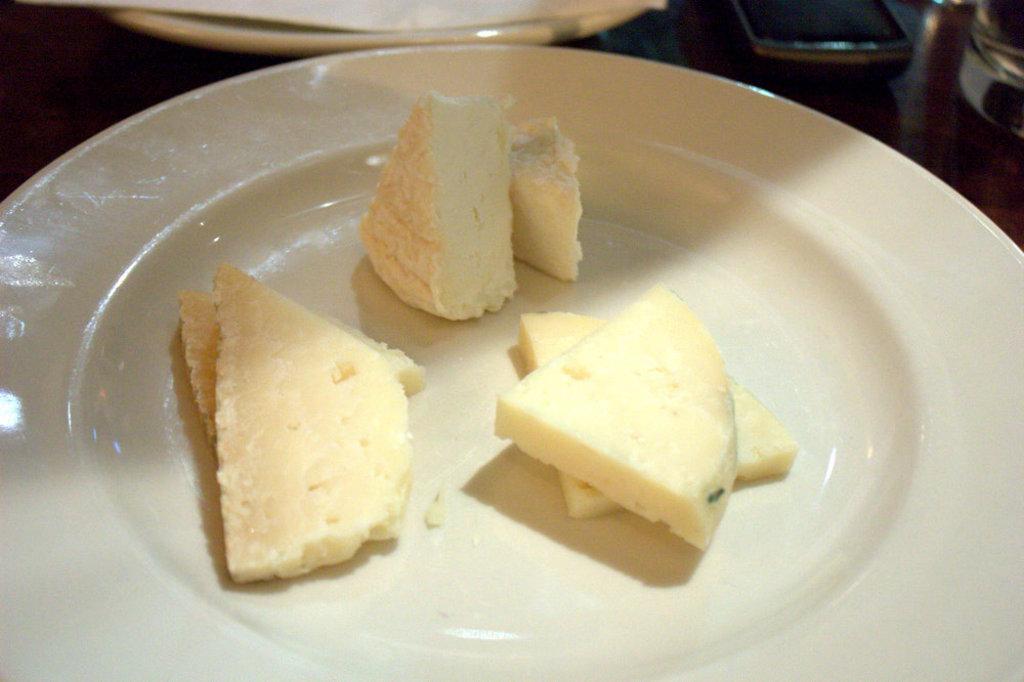How would you summarize this image in a sentence or two? In this picture I can see there is some food in the plate and there is another plate in the backdrop, there is a mobile phone and a glass of water on the table. 